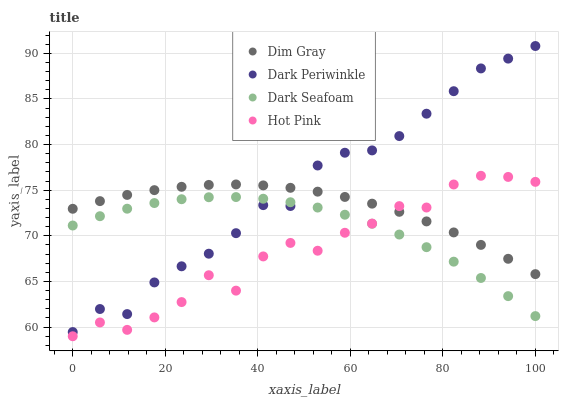Does Hot Pink have the minimum area under the curve?
Answer yes or no. Yes. Does Dark Periwinkle have the maximum area under the curve?
Answer yes or no. Yes. Does Dim Gray have the minimum area under the curve?
Answer yes or no. No. Does Dim Gray have the maximum area under the curve?
Answer yes or no. No. Is Dim Gray the smoothest?
Answer yes or no. Yes. Is Hot Pink the roughest?
Answer yes or no. Yes. Is Dark Periwinkle the smoothest?
Answer yes or no. No. Is Dark Periwinkle the roughest?
Answer yes or no. No. Does Hot Pink have the lowest value?
Answer yes or no. Yes. Does Dark Periwinkle have the lowest value?
Answer yes or no. No. Does Dark Periwinkle have the highest value?
Answer yes or no. Yes. Does Dim Gray have the highest value?
Answer yes or no. No. Is Hot Pink less than Dark Periwinkle?
Answer yes or no. Yes. Is Dark Periwinkle greater than Hot Pink?
Answer yes or no. Yes. Does Dim Gray intersect Hot Pink?
Answer yes or no. Yes. Is Dim Gray less than Hot Pink?
Answer yes or no. No. Is Dim Gray greater than Hot Pink?
Answer yes or no. No. Does Hot Pink intersect Dark Periwinkle?
Answer yes or no. No. 